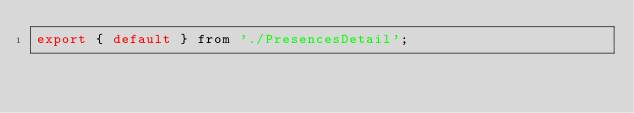Convert code to text. <code><loc_0><loc_0><loc_500><loc_500><_JavaScript_>export { default } from './PresencesDetail';</code> 